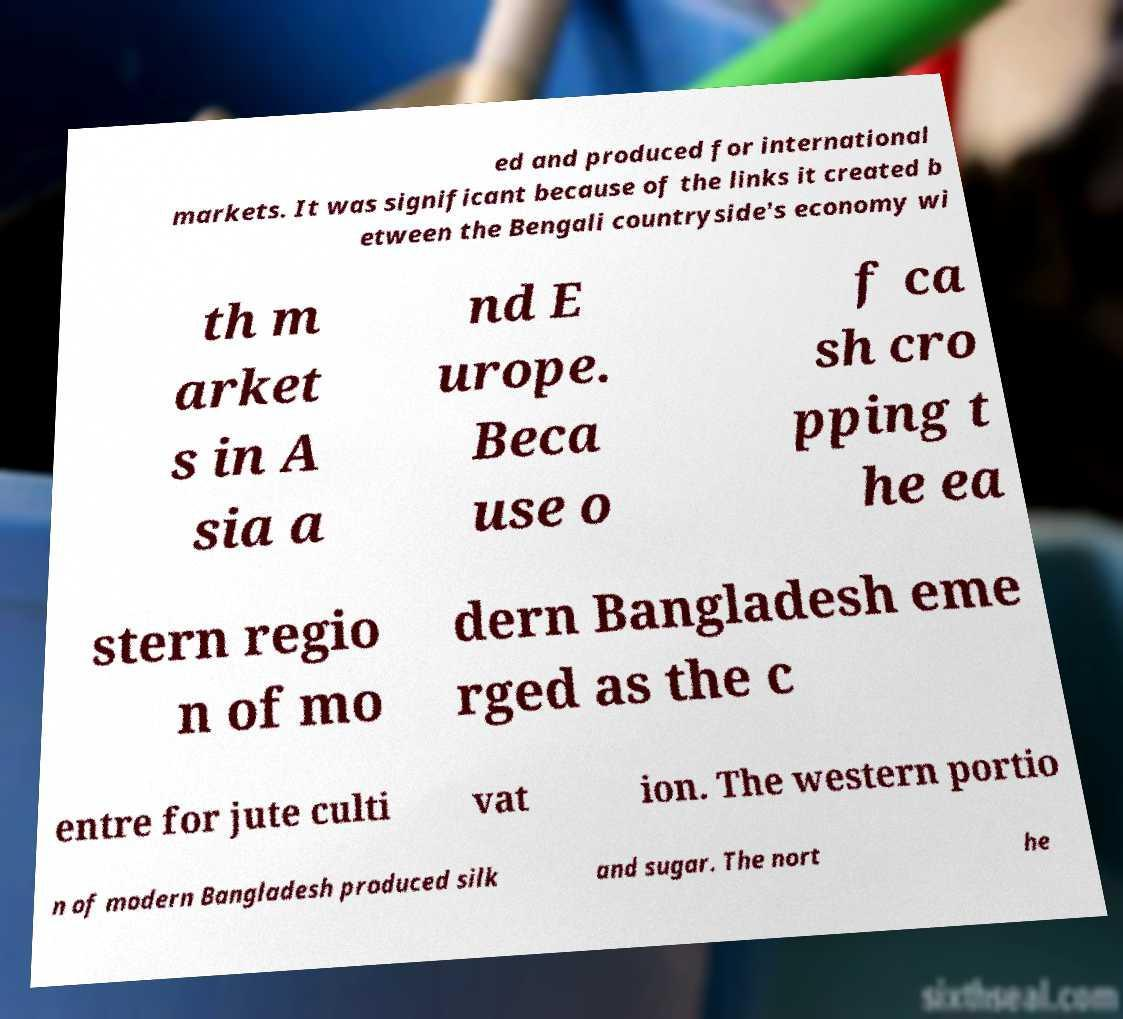For documentation purposes, I need the text within this image transcribed. Could you provide that? ed and produced for international markets. It was significant because of the links it created b etween the Bengali countryside's economy wi th m arket s in A sia a nd E urope. Beca use o f ca sh cro pping t he ea stern regio n of mo dern Bangladesh eme rged as the c entre for jute culti vat ion. The western portio n of modern Bangladesh produced silk and sugar. The nort he 